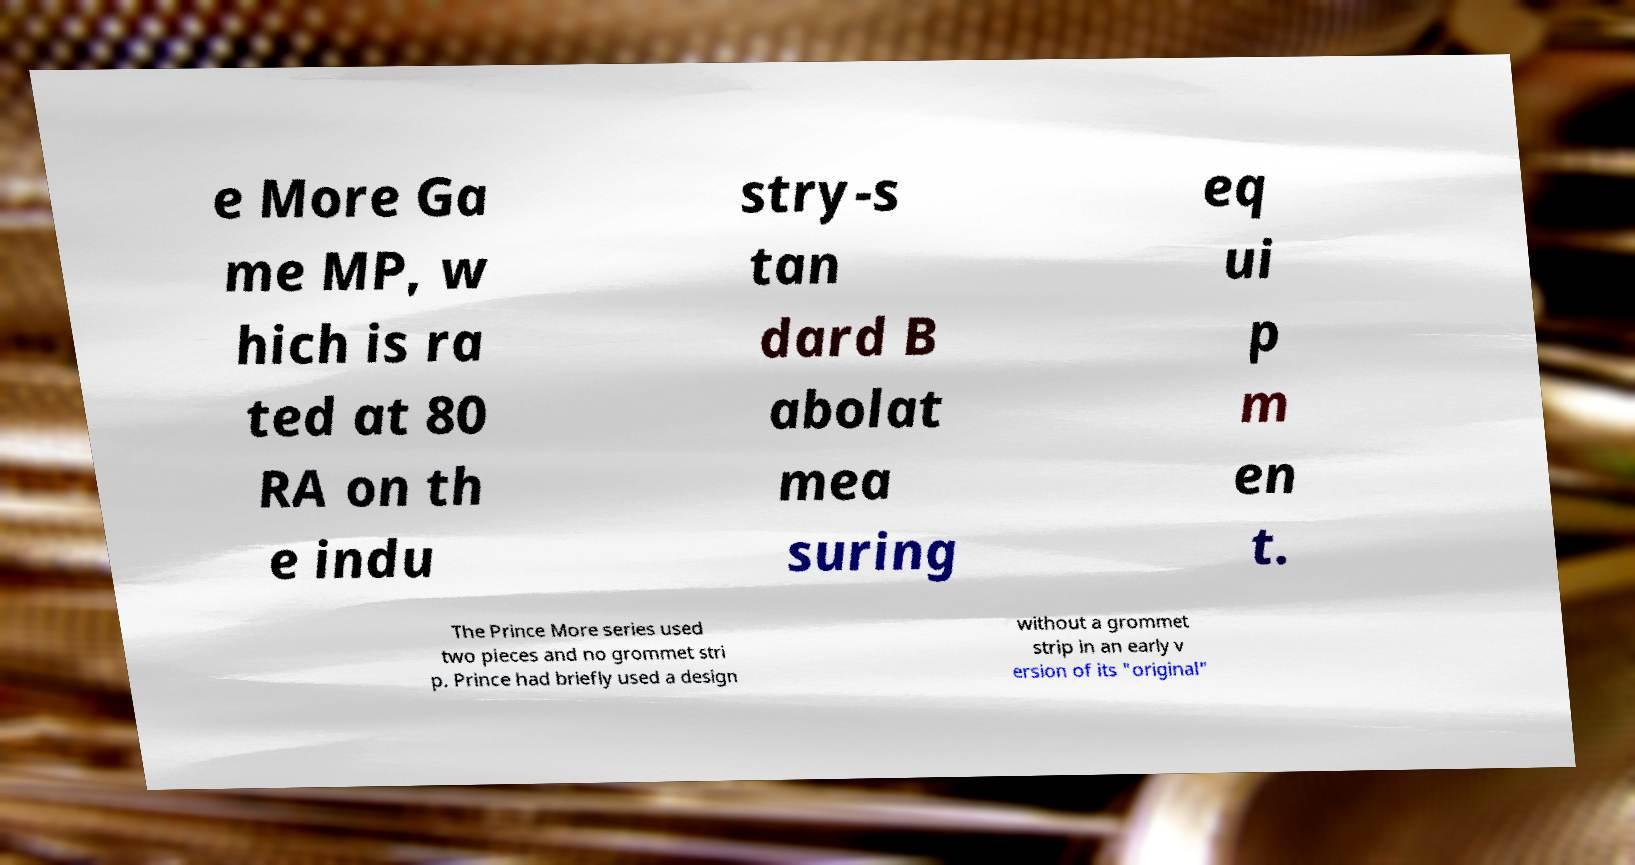There's text embedded in this image that I need extracted. Can you transcribe it verbatim? e More Ga me MP, w hich is ra ted at 80 RA on th e indu stry-s tan dard B abolat mea suring eq ui p m en t. The Prince More series used two pieces and no grommet stri p. Prince had briefly used a design without a grommet strip in an early v ersion of its "original" 